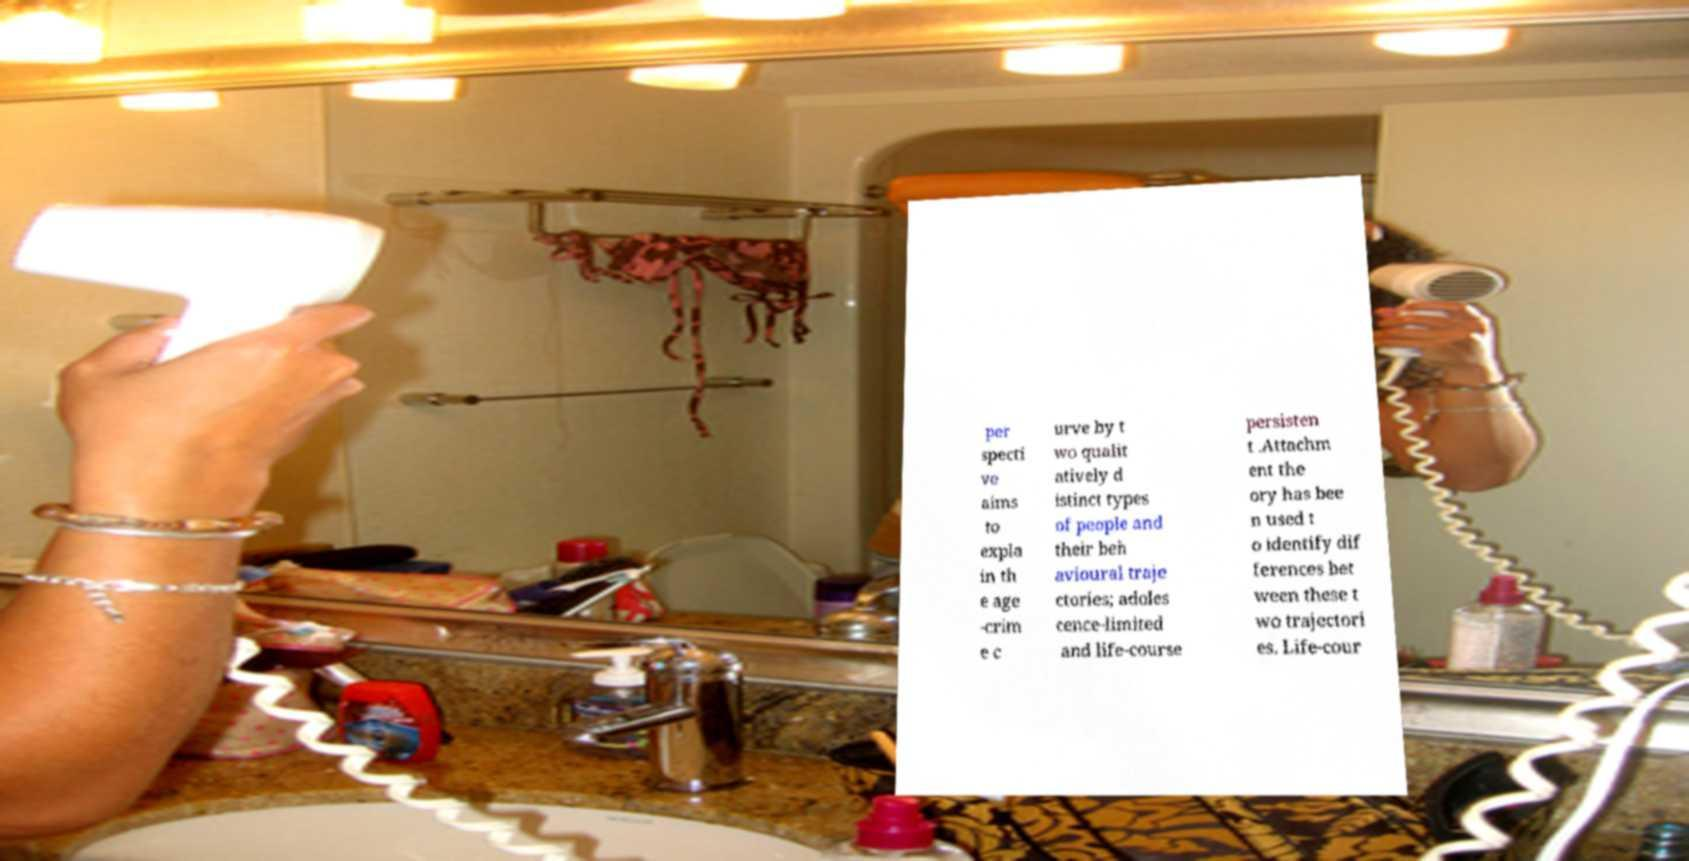Can you read and provide the text displayed in the image?This photo seems to have some interesting text. Can you extract and type it out for me? per specti ve aims to expla in th e age -crim e c urve by t wo qualit atively d istinct types of people and their beh avioural traje ctories; adoles cence-limited and life-course persisten t .Attachm ent the ory has bee n used t o identify dif ferences bet ween these t wo trajectori es. Life-cour 